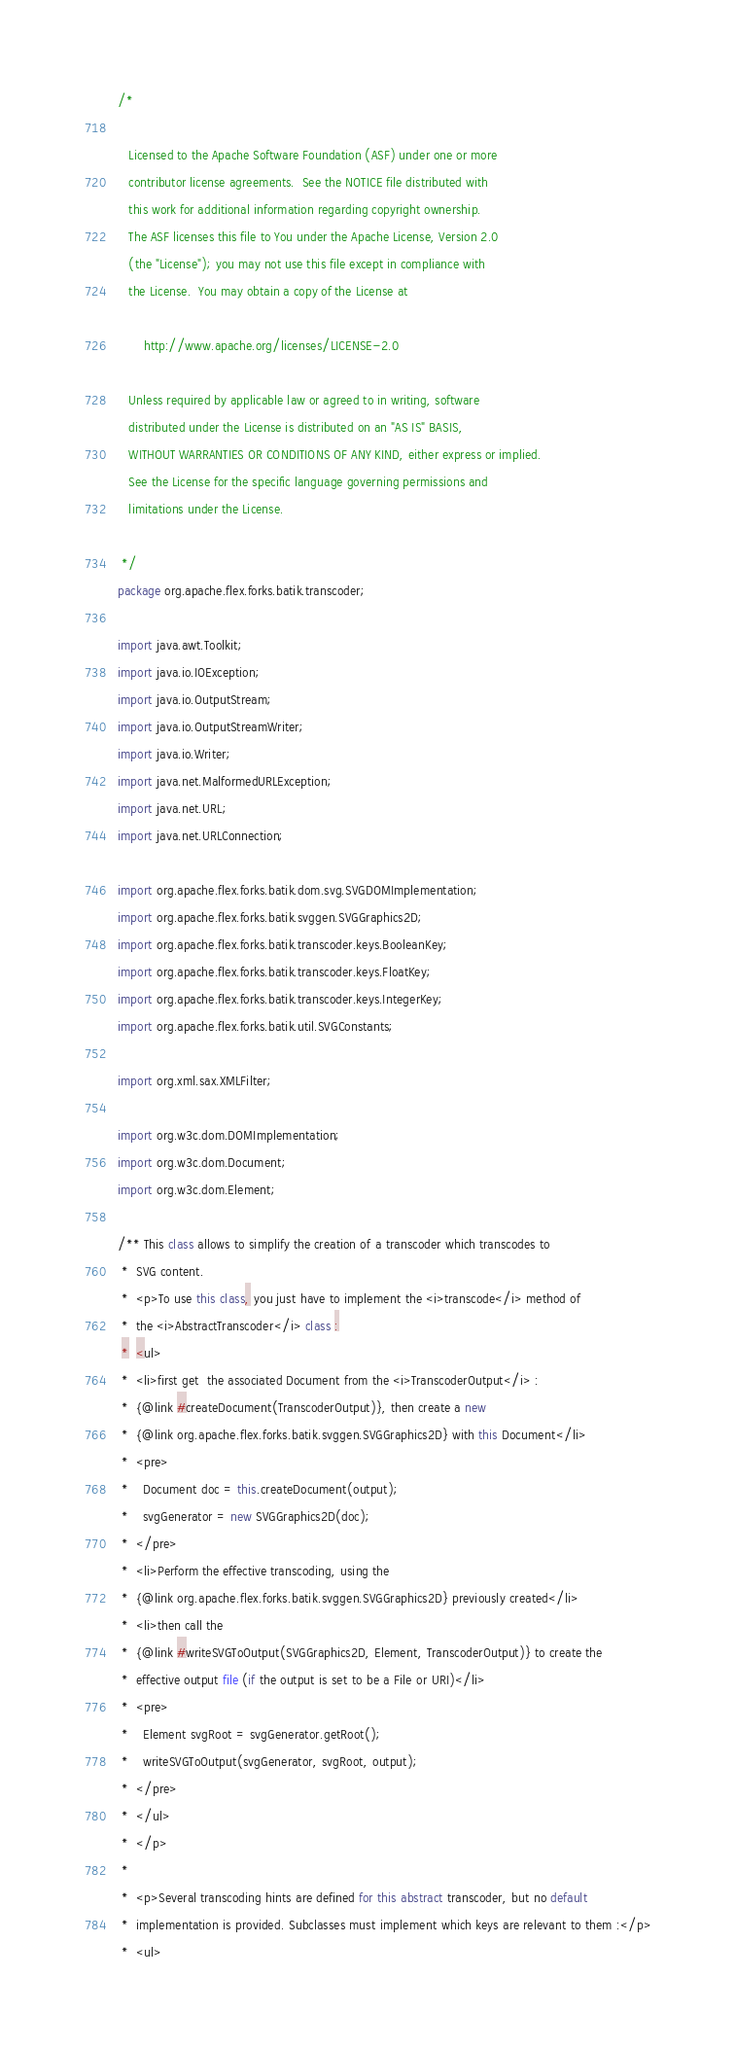Convert code to text. <code><loc_0><loc_0><loc_500><loc_500><_Java_>/*

   Licensed to the Apache Software Foundation (ASF) under one or more
   contributor license agreements.  See the NOTICE file distributed with
   this work for additional information regarding copyright ownership.
   The ASF licenses this file to You under the Apache License, Version 2.0
   (the "License"); you may not use this file except in compliance with
   the License.  You may obtain a copy of the License at

       http://www.apache.org/licenses/LICENSE-2.0

   Unless required by applicable law or agreed to in writing, software
   distributed under the License is distributed on an "AS IS" BASIS,
   WITHOUT WARRANTIES OR CONDITIONS OF ANY KIND, either express or implied.
   See the License for the specific language governing permissions and
   limitations under the License.

 */
package org.apache.flex.forks.batik.transcoder;

import java.awt.Toolkit;
import java.io.IOException;
import java.io.OutputStream;
import java.io.OutputStreamWriter;
import java.io.Writer;
import java.net.MalformedURLException;
import java.net.URL;
import java.net.URLConnection;

import org.apache.flex.forks.batik.dom.svg.SVGDOMImplementation;
import org.apache.flex.forks.batik.svggen.SVGGraphics2D;
import org.apache.flex.forks.batik.transcoder.keys.BooleanKey;
import org.apache.flex.forks.batik.transcoder.keys.FloatKey;
import org.apache.flex.forks.batik.transcoder.keys.IntegerKey;
import org.apache.flex.forks.batik.util.SVGConstants;

import org.xml.sax.XMLFilter;

import org.w3c.dom.DOMImplementation;
import org.w3c.dom.Document;
import org.w3c.dom.Element;

/** This class allows to simplify the creation of a transcoder which transcodes to
 *  SVG content.
 *  <p>To use this class, you just have to implement the <i>transcode</i> method of
 *  the <i>AbstractTranscoder</i> class :
 *  <ul>
 *  <li>first get  the associated Document from the <i>TranscoderOutput</i> :
 *  {@link #createDocument(TranscoderOutput)}, then create a new
 *  {@link org.apache.flex.forks.batik.svggen.SVGGraphics2D} with this Document</li>
 *  <pre>
 *    Document doc = this.createDocument(output);
 *    svgGenerator = new SVGGraphics2D(doc);
 *  </pre>
 *  <li>Perform the effective transcoding, using the
 *  {@link org.apache.flex.forks.batik.svggen.SVGGraphics2D} previously created</li>
 *  <li>then call the
 *  {@link #writeSVGToOutput(SVGGraphics2D, Element, TranscoderOutput)} to create the
 *  effective output file (if the output is set to be a File or URI)</li>
 *  <pre>
 *    Element svgRoot = svgGenerator.getRoot();
 *    writeSVGToOutput(svgGenerator, svgRoot, output);
 *  </pre>
 *  </ul>
 *  </p>
 *
 *  <p>Several transcoding hints are defined for this abstract transcoder, but no default
 *  implementation is provided. Subclasses must implement which keys are relevant to them :</p>
 *  <ul></code> 